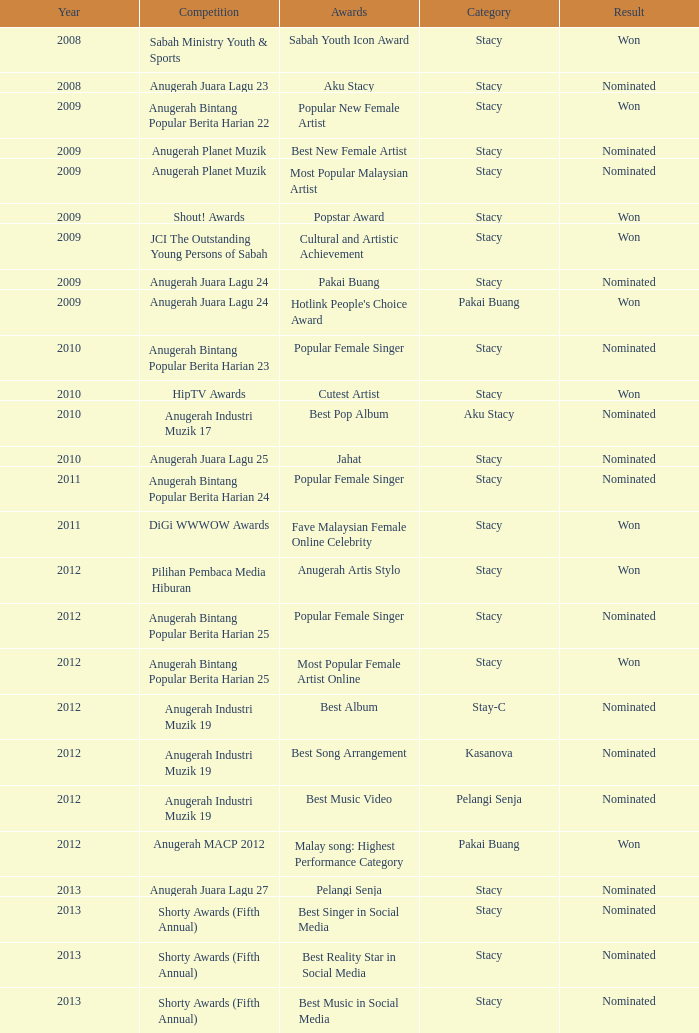What accolade was in the year following 2009 with a contest of digi wwwow awards? Fave Malaysian Female Online Celebrity. 